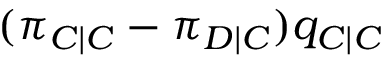<formula> <loc_0><loc_0><loc_500><loc_500>( \pi _ { C | C } - \pi _ { D | C } ) q _ { C | C }</formula> 